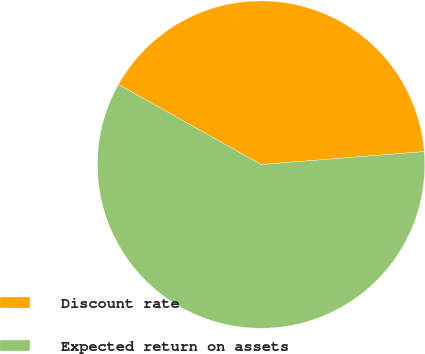Convert chart to OTSL. <chart><loc_0><loc_0><loc_500><loc_500><pie_chart><fcel>Discount rate<fcel>Expected return on assets<nl><fcel>40.6%<fcel>59.4%<nl></chart> 